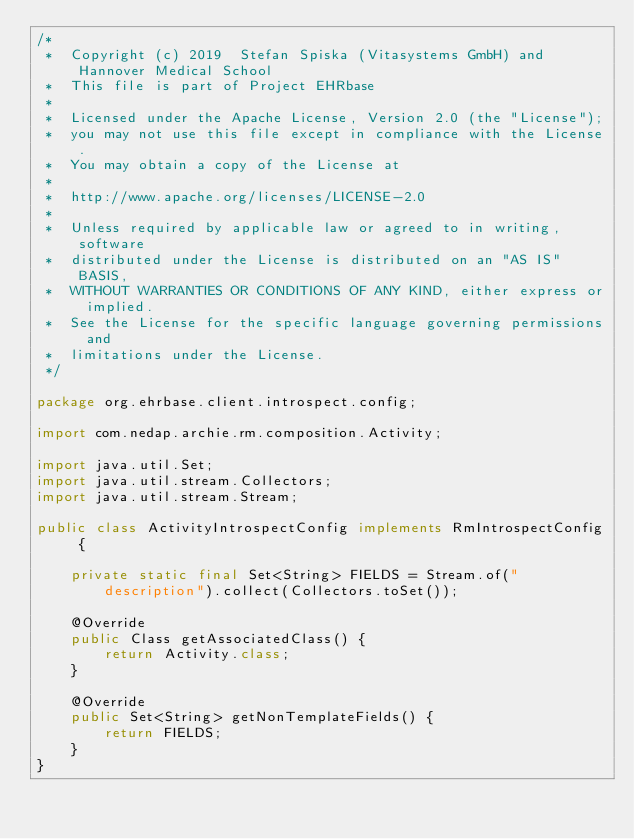<code> <loc_0><loc_0><loc_500><loc_500><_Java_>/*
 *  Copyright (c) 2019  Stefan Spiska (Vitasystems GmbH) and Hannover Medical School
 *  This file is part of Project EHRbase
 *
 *  Licensed under the Apache License, Version 2.0 (the "License");
 *  you may not use this file except in compliance with the License.
 *  You may obtain a copy of the License at
 *
 *  http://www.apache.org/licenses/LICENSE-2.0
 *
 *  Unless required by applicable law or agreed to in writing, software
 *  distributed under the License is distributed on an "AS IS" BASIS,
 *  WITHOUT WARRANTIES OR CONDITIONS OF ANY KIND, either express or implied.
 *  See the License for the specific language governing permissions and
 *  limitations under the License.
 */

package org.ehrbase.client.introspect.config;

import com.nedap.archie.rm.composition.Activity;

import java.util.Set;
import java.util.stream.Collectors;
import java.util.stream.Stream;

public class ActivityIntrospectConfig implements RmIntrospectConfig {

    private static final Set<String> FIELDS = Stream.of("description").collect(Collectors.toSet());

    @Override
    public Class getAssociatedClass() {
        return Activity.class;
    }

    @Override
    public Set<String> getNonTemplateFields() {
        return FIELDS;
    }
}
</code> 